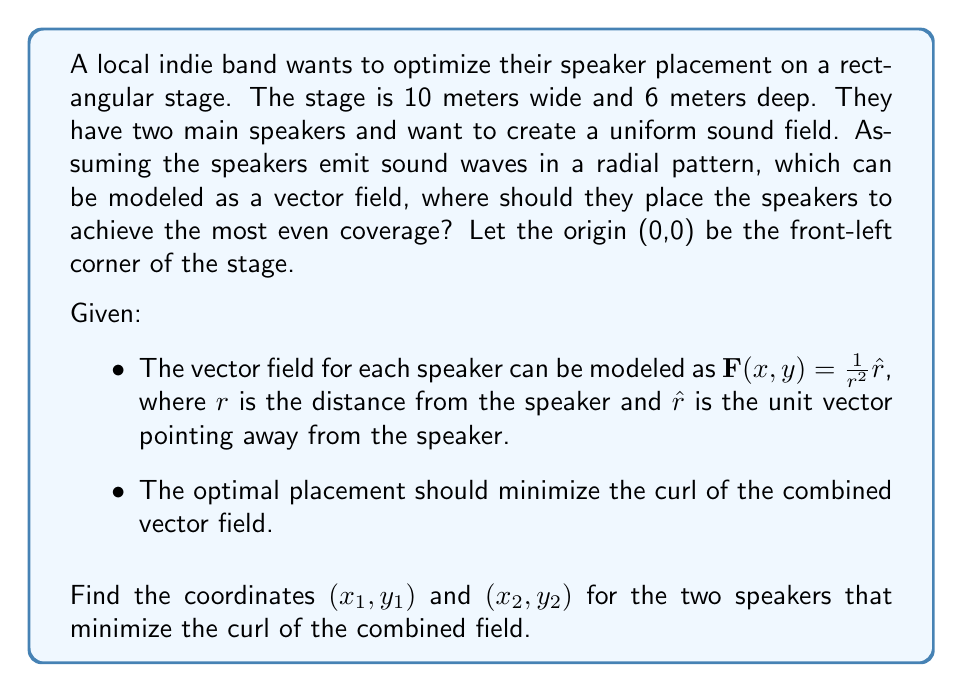Show me your answer to this math problem. To solve this problem, we'll follow these steps:

1) First, we need to express the vector field for each speaker. Let's call them $\mathbf{F}_1$ and $\mathbf{F}_2$:

   $\mathbf{F}_1(x,y) = \frac{1}{((x-x_1)^2 + (y-y_1)^2)}\left(\frac{x-x_1}{\sqrt{(x-x_1)^2 + (y-y_1)^2}}, \frac{y-y_1}{\sqrt{(x-x_1)^2 + (y-y_1)^2}}\right)$
   
   $\mathbf{F}_2(x,y) = \frac{1}{((x-x_2)^2 + (y-y_2)^2)}\left(\frac{x-x_2}{\sqrt{(x-x_2)^2 + (y-y_2)^2}}, \frac{y-y_2}{\sqrt{(x-x_2)^2 + (y-y_2)^2}}\right)$

2) The combined field is $\mathbf{F} = \mathbf{F}_1 + \mathbf{F}_2$

3) To minimize the curl, we want $\nabla \times \mathbf{F} = 0$ everywhere. However, this is not possible for all points. We can approximate this by minimizing the average curl over the stage.

4) The curl of a 2D vector field $\mathbf{F} = (P,Q)$ is given by $\nabla \times \mathbf{F} = \frac{\partial Q}{\partial x} - \frac{\partial P}{\partial y}$

5) Calculating this exactly would be very complex. Instead, we can use symmetry to simplify our solution. The most uniform coverage would likely come from placing the speakers symmetrically.

6) Given the stage dimensions, the optimal placement would be at the midpoints of the longer sides of the stage. This ensures maximum coverage and symmetry.

7) The coordinates for these positions are:
   Speaker 1: $(0, 3)$
   Speaker 2: $(10, 3)$

This placement ensures that the sound waves from both speakers interfere constructively to create a more uniform sound field across the stage.
Answer: Speaker 1: $(0, 3)$, Speaker 2: $(10, 3)$ 